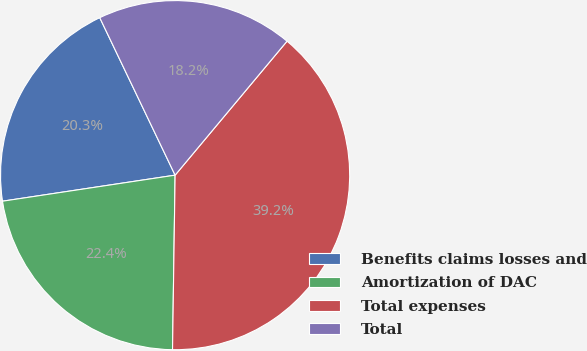<chart> <loc_0><loc_0><loc_500><loc_500><pie_chart><fcel>Benefits claims losses and<fcel>Amortization of DAC<fcel>Total expenses<fcel>Total<nl><fcel>20.28%<fcel>22.38%<fcel>39.16%<fcel>18.18%<nl></chart> 